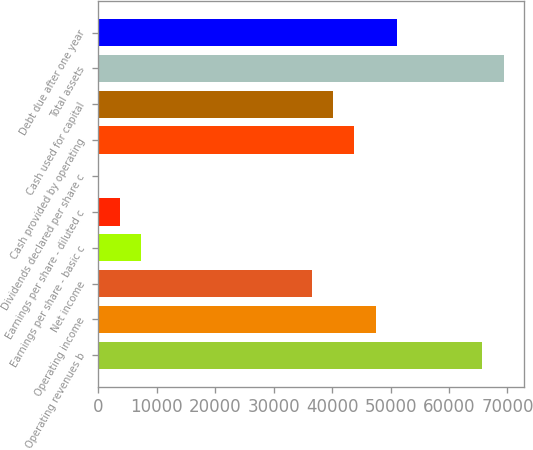Convert chart. <chart><loc_0><loc_0><loc_500><loc_500><bar_chart><fcel>Operating revenues b<fcel>Operating income<fcel>Net income<fcel>Earnings per share - basic c<fcel>Earnings per share - diluted c<fcel>Dividends declared per share c<fcel>Cash provided by operating<fcel>Cash used for capital<fcel>Total assets<fcel>Debt due after one year<nl><fcel>65726.5<fcel>47469.3<fcel>36515<fcel>7303.48<fcel>3652.04<fcel>0.6<fcel>43817.9<fcel>40166.4<fcel>69378<fcel>51120.8<nl></chart> 